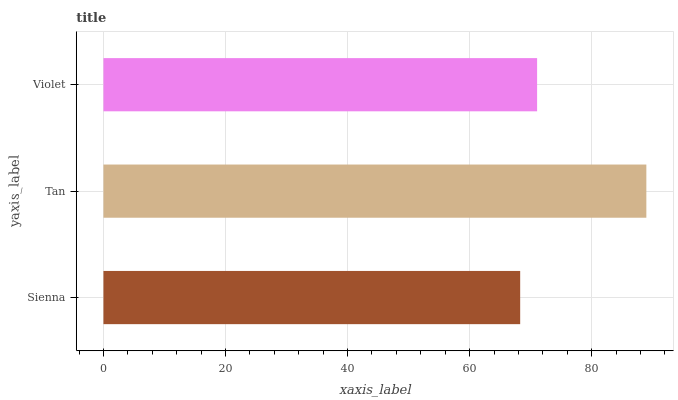Is Sienna the minimum?
Answer yes or no. Yes. Is Tan the maximum?
Answer yes or no. Yes. Is Violet the minimum?
Answer yes or no. No. Is Violet the maximum?
Answer yes or no. No. Is Tan greater than Violet?
Answer yes or no. Yes. Is Violet less than Tan?
Answer yes or no. Yes. Is Violet greater than Tan?
Answer yes or no. No. Is Tan less than Violet?
Answer yes or no. No. Is Violet the high median?
Answer yes or no. Yes. Is Violet the low median?
Answer yes or no. Yes. Is Tan the high median?
Answer yes or no. No. Is Tan the low median?
Answer yes or no. No. 